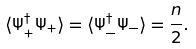<formula> <loc_0><loc_0><loc_500><loc_500>\langle \Psi ^ { \dagger } _ { + } \Psi _ { + } \rangle = \langle \Psi ^ { \dagger } _ { - } \Psi _ { - } \rangle = \frac { n } { 2 } .</formula> 